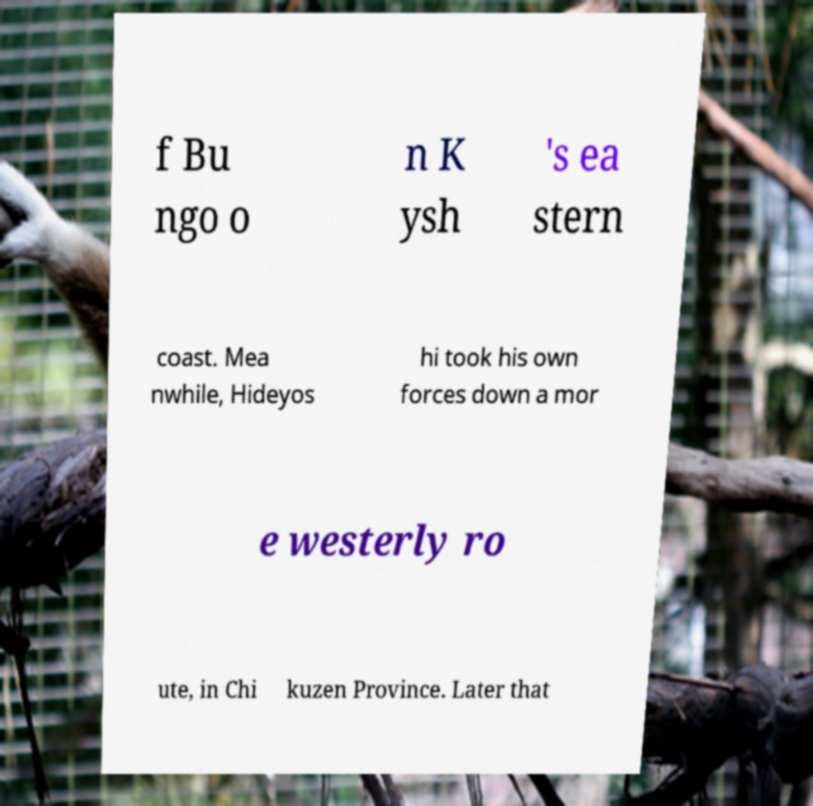Please identify and transcribe the text found in this image. f Bu ngo o n K ysh 's ea stern coast. Mea nwhile, Hideyos hi took his own forces down a mor e westerly ro ute, in Chi kuzen Province. Later that 